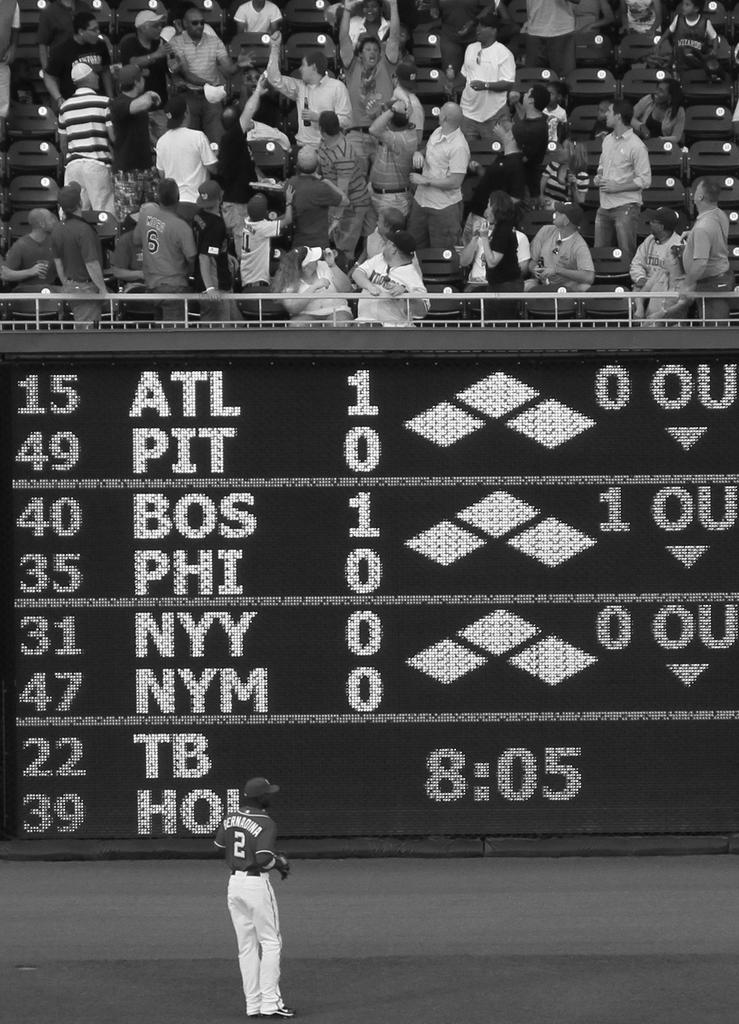<image>
Render a clear and concise summary of the photo. people in stands trying to find ball while player #2 bernadina stands in the outfield 